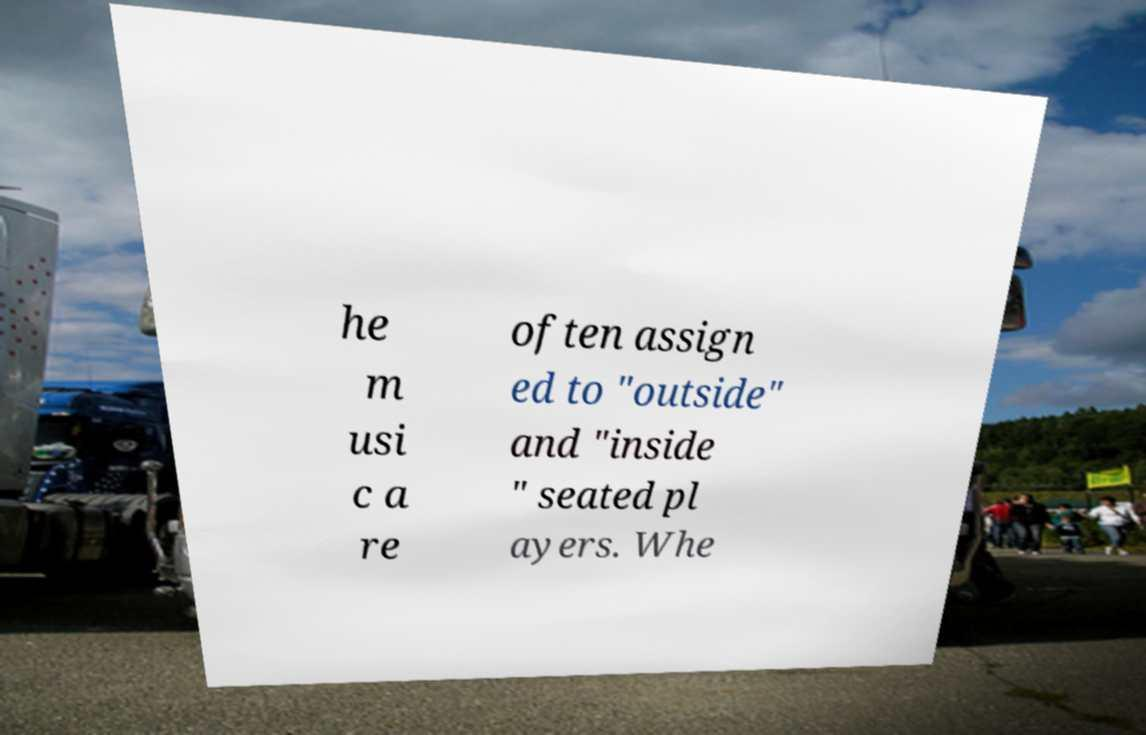Please read and relay the text visible in this image. What does it say? he m usi c a re often assign ed to "outside" and "inside " seated pl ayers. Whe 